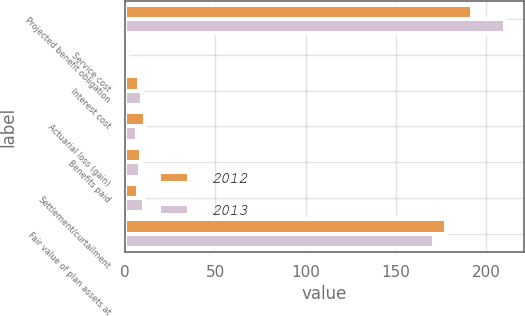<chart> <loc_0><loc_0><loc_500><loc_500><stacked_bar_chart><ecel><fcel>Projected benefit obligation<fcel>Service cost<fcel>Interest cost<fcel>Actuarial loss (gain)<fcel>Benefits paid<fcel>Settlement/curtailment<fcel>Fair value of plan assets at<nl><fcel>2012<fcel>192.2<fcel>1.3<fcel>7.9<fcel>11.3<fcel>8.7<fcel>7.1<fcel>177.6<nl><fcel>2013<fcel>210.1<fcel>1.2<fcel>9.3<fcel>6.4<fcel>8.2<fcel>10.7<fcel>171.2<nl></chart> 